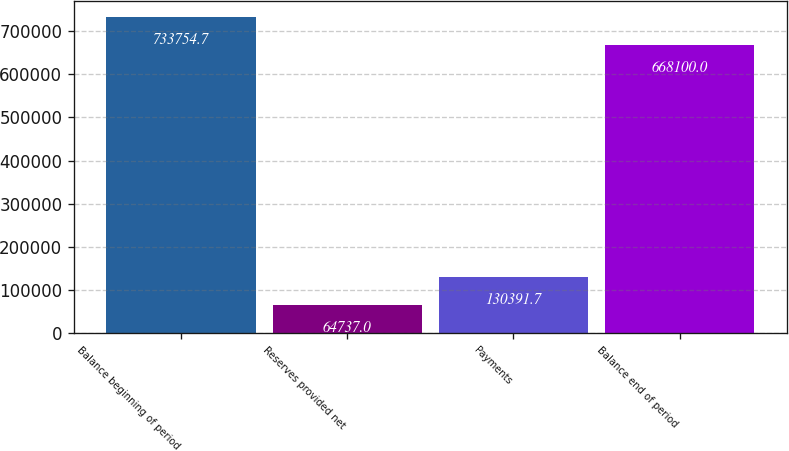Convert chart to OTSL. <chart><loc_0><loc_0><loc_500><loc_500><bar_chart><fcel>Balance beginning of period<fcel>Reserves provided net<fcel>Payments<fcel>Balance end of period<nl><fcel>733755<fcel>64737<fcel>130392<fcel>668100<nl></chart> 